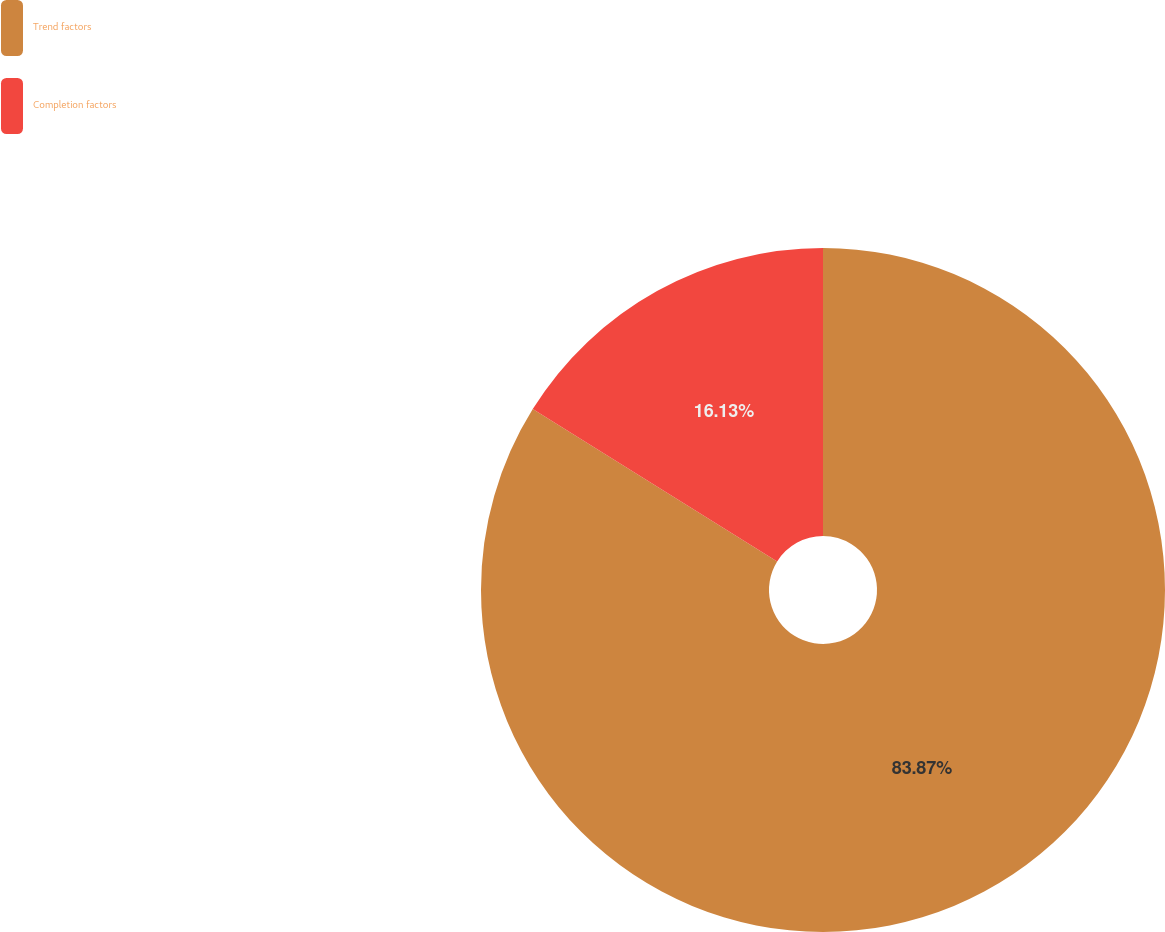<chart> <loc_0><loc_0><loc_500><loc_500><pie_chart><fcel>Trend factors<fcel>Completion factors<nl><fcel>83.87%<fcel>16.13%<nl></chart> 